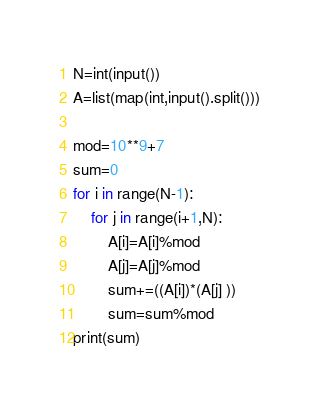<code> <loc_0><loc_0><loc_500><loc_500><_Python_>N=int(input())
A=list(map(int,input().split()))

mod=10**9+7
sum=0
for i in range(N-1):
    for j in range(i+1,N):
        A[i]=A[i]%mod
        A[j]=A[j]%mod
        sum+=((A[i])*(A[j] ))
        sum=sum%mod
print(sum)</code> 